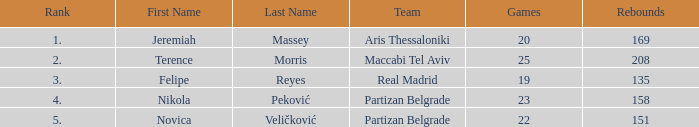How many Rebounds did Novica Veličković get in less than 22 Games? None. 